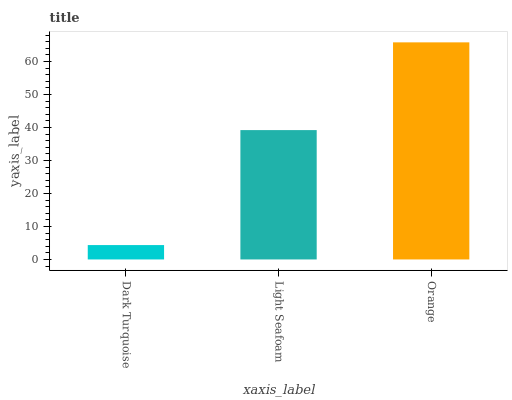Is Light Seafoam the minimum?
Answer yes or no. No. Is Light Seafoam the maximum?
Answer yes or no. No. Is Light Seafoam greater than Dark Turquoise?
Answer yes or no. Yes. Is Dark Turquoise less than Light Seafoam?
Answer yes or no. Yes. Is Dark Turquoise greater than Light Seafoam?
Answer yes or no. No. Is Light Seafoam less than Dark Turquoise?
Answer yes or no. No. Is Light Seafoam the high median?
Answer yes or no. Yes. Is Light Seafoam the low median?
Answer yes or no. Yes. Is Dark Turquoise the high median?
Answer yes or no. No. Is Orange the low median?
Answer yes or no. No. 